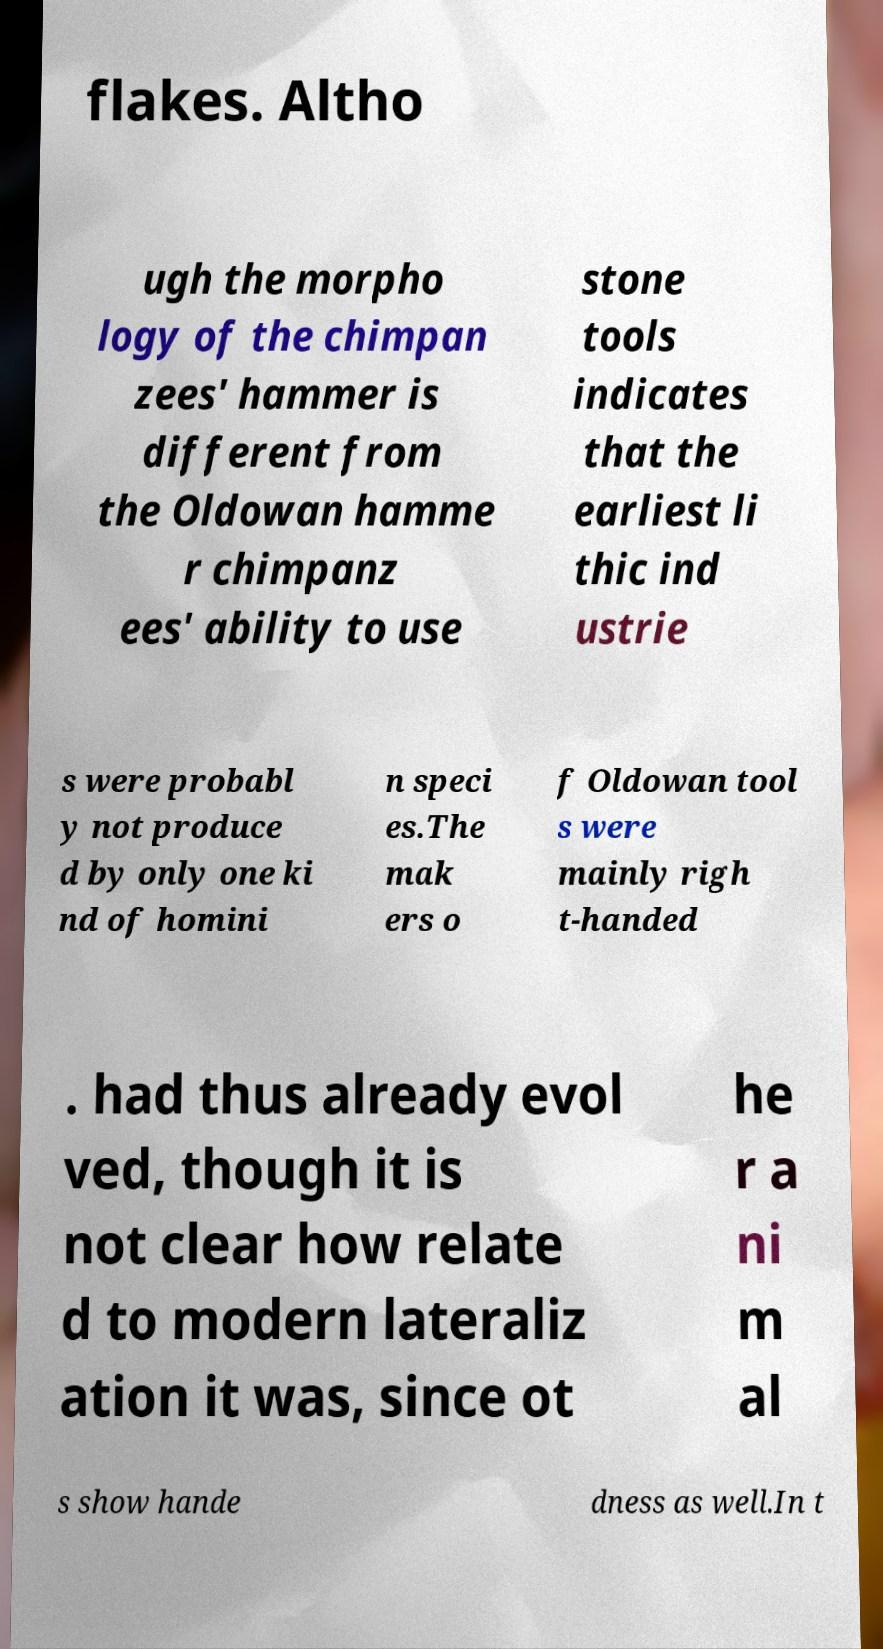Can you read and provide the text displayed in the image?This photo seems to have some interesting text. Can you extract and type it out for me? flakes. Altho ugh the morpho logy of the chimpan zees' hammer is different from the Oldowan hamme r chimpanz ees' ability to use stone tools indicates that the earliest li thic ind ustrie s were probabl y not produce d by only one ki nd of homini n speci es.The mak ers o f Oldowan tool s were mainly righ t-handed . had thus already evol ved, though it is not clear how relate d to modern lateraliz ation it was, since ot he r a ni m al s show hande dness as well.In t 